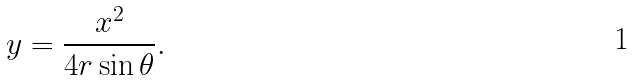Convert formula to latex. <formula><loc_0><loc_0><loc_500><loc_500>y = { \frac { x ^ { 2 } } { 4 r \sin \theta } } .</formula> 